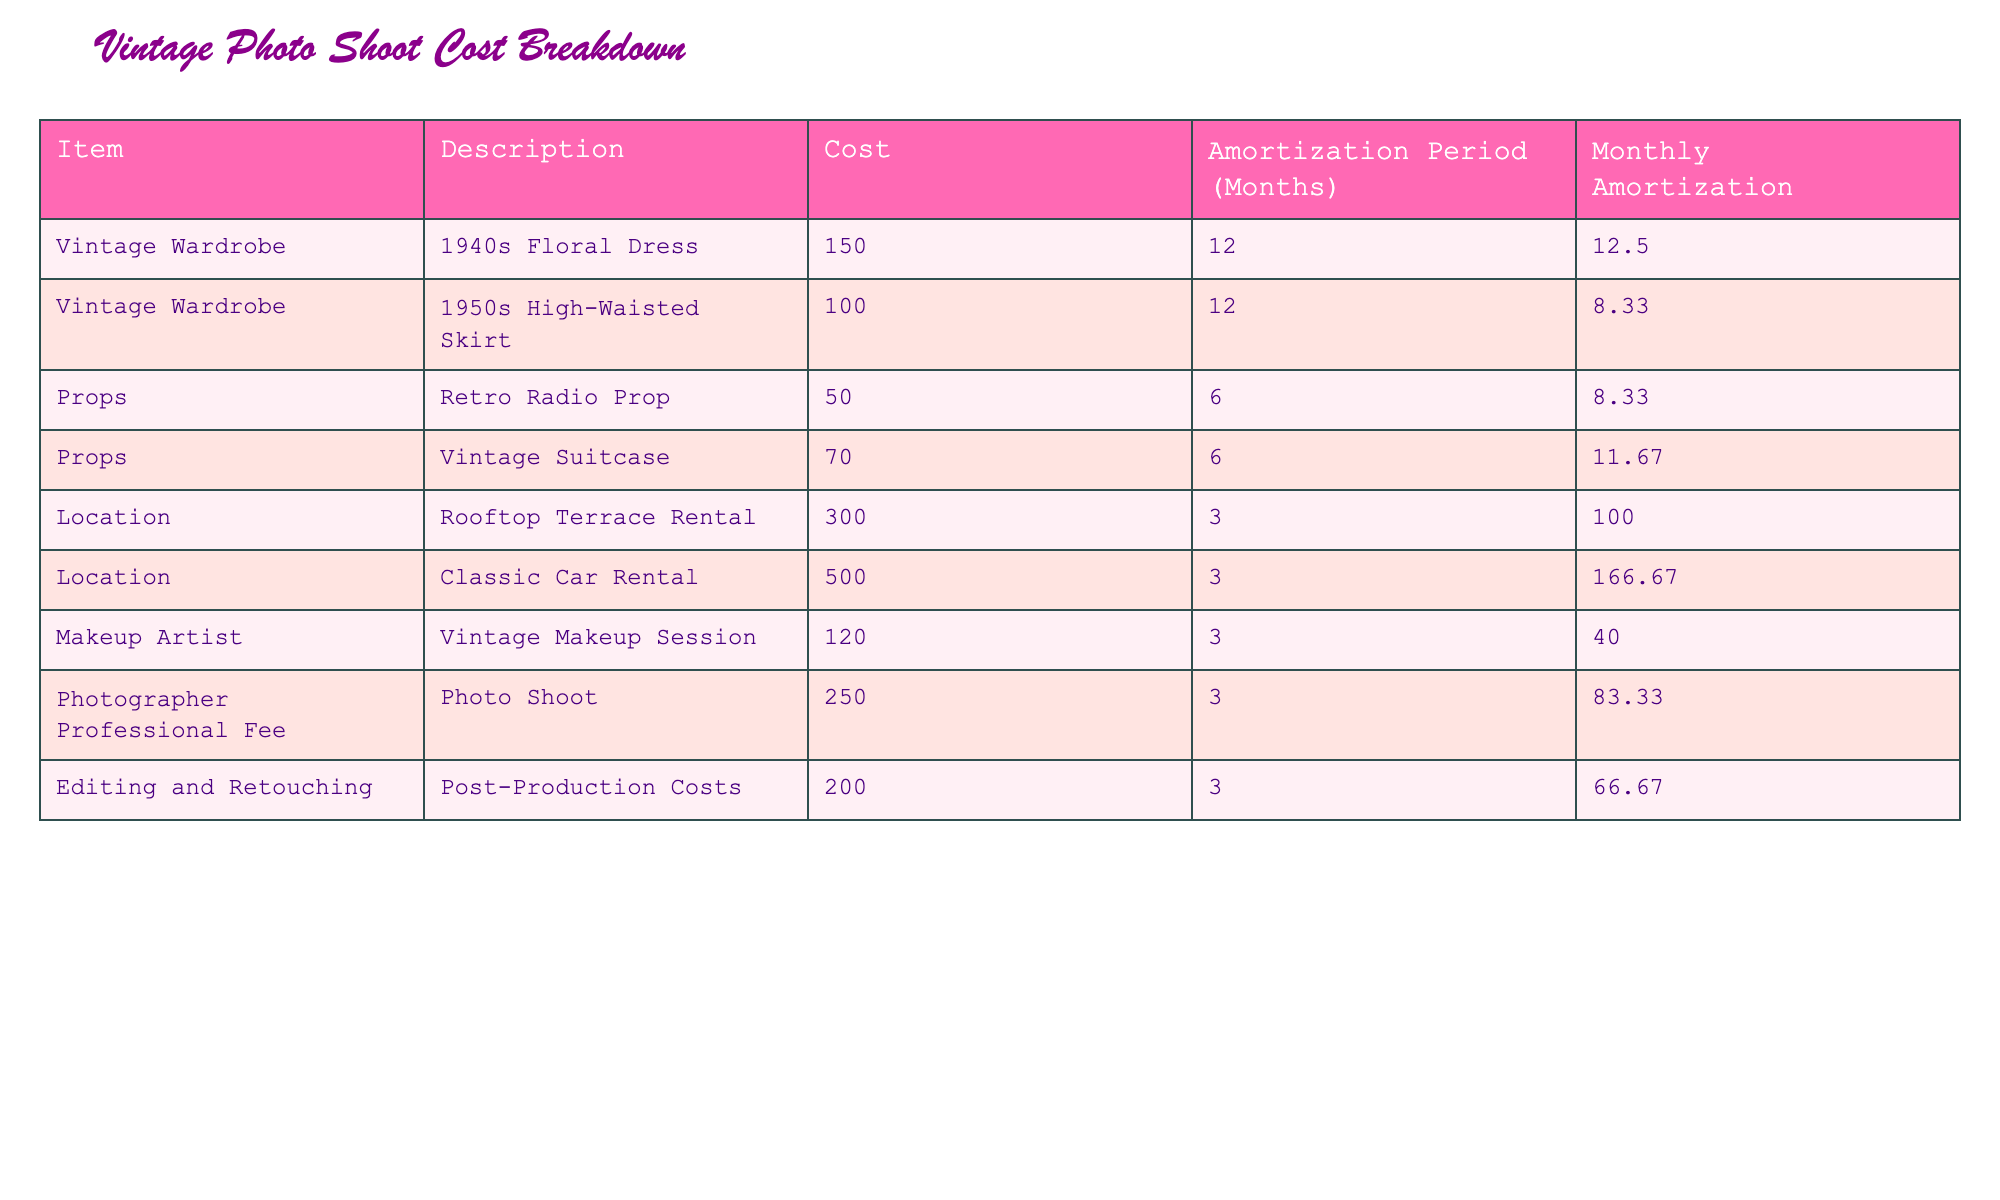What is the total cost of the vintage wardrobe items? To find the total cost of the vintage wardrobe items, I will look at the specific costs listed for the two wardrobe items: 150 for the 1940s Floral Dress and 100 for the 1950s High-Waisted Skirt. Adding these together gives 150 + 100 = 250.
Answer: 250 How much is the monthly amortization for the Rooftop Terrace Rental? The monthly amortization for the Rooftop Terrace Rental can be directly found in the table, where it is indicated as 100.00.
Answer: 100.00 Is the cost for the Vintage Suitcase higher than the Retro Radio Prop? The cost for the Vintage Suitcase is 70, while the cost for the Retro Radio Prop is 50. Since 70 is greater than 50, the statement is true.
Answer: Yes What is the average monthly amortization for all items listed? To find the average monthly amortization, I will sum all the monthly amortizations: 12.50 + 8.33 + 8.33 + 11.67 + 100 + 166.67 + 40 + 83.33 + 66.67 = 497.50. There are 9 items, so I divide by 9: 497.50 / 9 ≈ 55.28.
Answer: 55.28 What is the total amortization period for all props? The table indicates that there are two prop items: the Retro Radio Prop with an amortization period of 6 months and the Vintage Suitcase also with an amortization period of 6 months. To find the total, I add both: 6 + 6 = 12.
Answer: 12 Which item has the highest cost? Scanning through the costs listed in the table, the Classic Car Rental is the highest at 500. No other item has a cost exceeding this amount.
Answer: Classic Car Rental What is the difference in monthly amortization between the most expensive and the least expensive item? The most expensive item is the Classic Car Rental with a monthly amortization of 166.67, while the least expensive monthly amortization is for the 1950s High-Waisted Skirt at 8.33. The difference is calculated as 166.67 - 8.33 = 158.34.
Answer: 158.34 Are all locations in the table amortized over a period of less than 6 months? The Rooftop Terrace Rental and the Classic Car Rental both have amortization periods of 3 months, which are indeed less than 6. Therefore, the statement is true.
Answer: Yes What is the combined monthly amortization for all makeup and editing costs? The monthly amortization for the Vintage Makeup Session is 40.00, and for Post-Production Costs, it is 66.67. The combined total is 40.00 + 66.67 = 106.67.
Answer: 106.67 